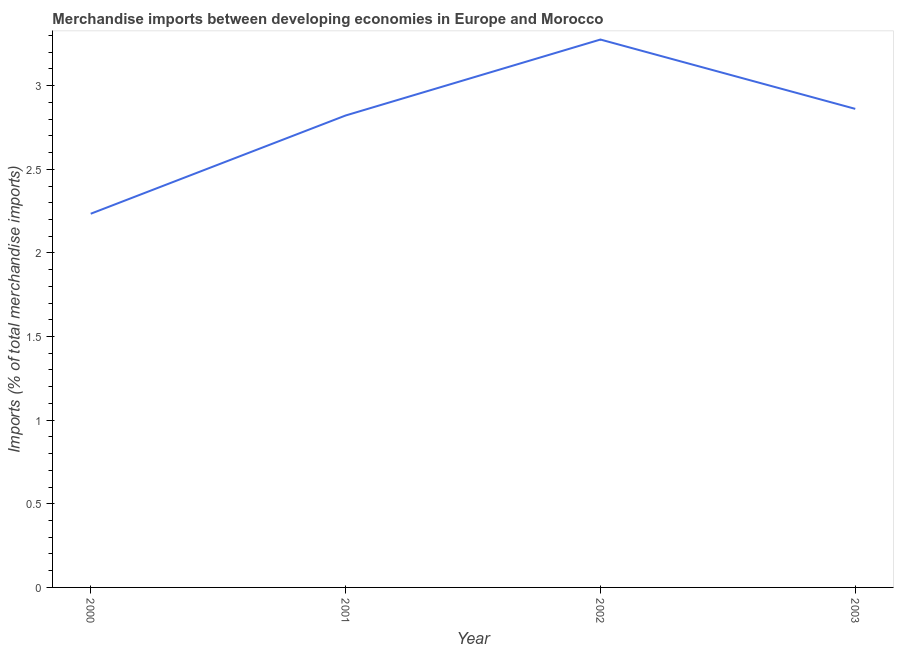What is the merchandise imports in 2002?
Offer a terse response. 3.28. Across all years, what is the maximum merchandise imports?
Give a very brief answer. 3.28. Across all years, what is the minimum merchandise imports?
Your answer should be very brief. 2.23. In which year was the merchandise imports maximum?
Provide a succinct answer. 2002. In which year was the merchandise imports minimum?
Make the answer very short. 2000. What is the sum of the merchandise imports?
Ensure brevity in your answer.  11.19. What is the difference between the merchandise imports in 2002 and 2003?
Provide a succinct answer. 0.41. What is the average merchandise imports per year?
Your answer should be very brief. 2.8. What is the median merchandise imports?
Your answer should be very brief. 2.84. What is the ratio of the merchandise imports in 2001 to that in 2002?
Keep it short and to the point. 0.86. Is the difference between the merchandise imports in 2000 and 2002 greater than the difference between any two years?
Your answer should be very brief. Yes. What is the difference between the highest and the second highest merchandise imports?
Provide a succinct answer. 0.41. Is the sum of the merchandise imports in 2001 and 2002 greater than the maximum merchandise imports across all years?
Give a very brief answer. Yes. What is the difference between the highest and the lowest merchandise imports?
Your response must be concise. 1.04. How many lines are there?
Offer a very short reply. 1. What is the difference between two consecutive major ticks on the Y-axis?
Provide a succinct answer. 0.5. What is the title of the graph?
Give a very brief answer. Merchandise imports between developing economies in Europe and Morocco. What is the label or title of the Y-axis?
Give a very brief answer. Imports (% of total merchandise imports). What is the Imports (% of total merchandise imports) in 2000?
Make the answer very short. 2.23. What is the Imports (% of total merchandise imports) in 2001?
Offer a very short reply. 2.82. What is the Imports (% of total merchandise imports) of 2002?
Give a very brief answer. 3.28. What is the Imports (% of total merchandise imports) in 2003?
Provide a short and direct response. 2.86. What is the difference between the Imports (% of total merchandise imports) in 2000 and 2001?
Provide a short and direct response. -0.59. What is the difference between the Imports (% of total merchandise imports) in 2000 and 2002?
Your answer should be very brief. -1.04. What is the difference between the Imports (% of total merchandise imports) in 2000 and 2003?
Make the answer very short. -0.63. What is the difference between the Imports (% of total merchandise imports) in 2001 and 2002?
Provide a short and direct response. -0.45. What is the difference between the Imports (% of total merchandise imports) in 2001 and 2003?
Keep it short and to the point. -0.04. What is the difference between the Imports (% of total merchandise imports) in 2002 and 2003?
Provide a succinct answer. 0.41. What is the ratio of the Imports (% of total merchandise imports) in 2000 to that in 2001?
Your answer should be very brief. 0.79. What is the ratio of the Imports (% of total merchandise imports) in 2000 to that in 2002?
Give a very brief answer. 0.68. What is the ratio of the Imports (% of total merchandise imports) in 2000 to that in 2003?
Provide a succinct answer. 0.78. What is the ratio of the Imports (% of total merchandise imports) in 2001 to that in 2002?
Give a very brief answer. 0.86. What is the ratio of the Imports (% of total merchandise imports) in 2001 to that in 2003?
Offer a very short reply. 0.99. What is the ratio of the Imports (% of total merchandise imports) in 2002 to that in 2003?
Provide a succinct answer. 1.15. 